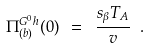<formula> <loc_0><loc_0><loc_500><loc_500>\Pi ^ { G ^ { 0 } h } _ { ( b ) } ( 0 ) \ = \ \frac { s _ { \beta } T _ { A } } { v } \ .</formula> 